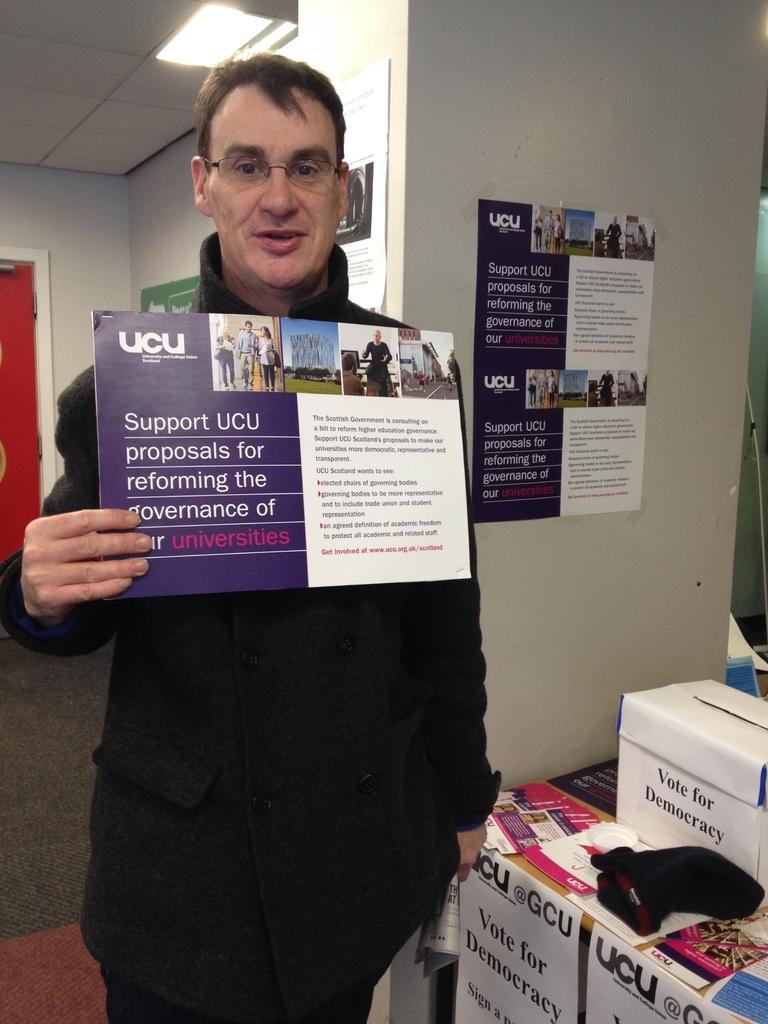Why should ucu be supported?
Ensure brevity in your answer.  Reforming the government. 